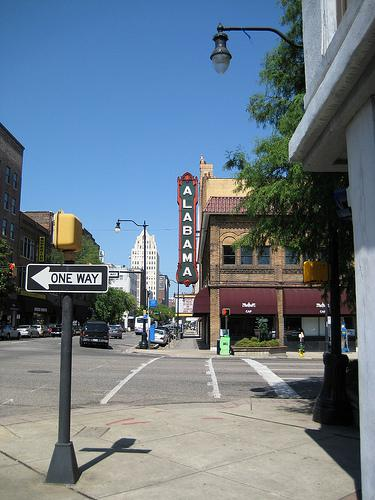Question: when is the photo taken?
Choices:
A. Afternoon.
B. At night.
C. Clear sky day.
D. Cloudy day.
Answer with the letter. Answer: C Question: where is the cross walk?
Choices:
A. Front Burgundy building.
B. At the corner.
C. By the bus stop.
D. In front of the cafe.
Answer with the letter. Answer: A Question: what color is the cross walk light above the one way sign?
Choices:
A. Red.
B. Green.
C. Blue.
D. Yellow.
Answer with the letter. Answer: D Question: how many street lights are in the photo?
Choices:
A. None.
B. 2.
C. 1.
D. 4.
Answer with the letter. Answer: B Question: what color is the buildings umbrella shade?
Choices:
A. Black and white.
B. Blue.
C. Burgundy.
D. Pink.
Answer with the letter. Answer: C 